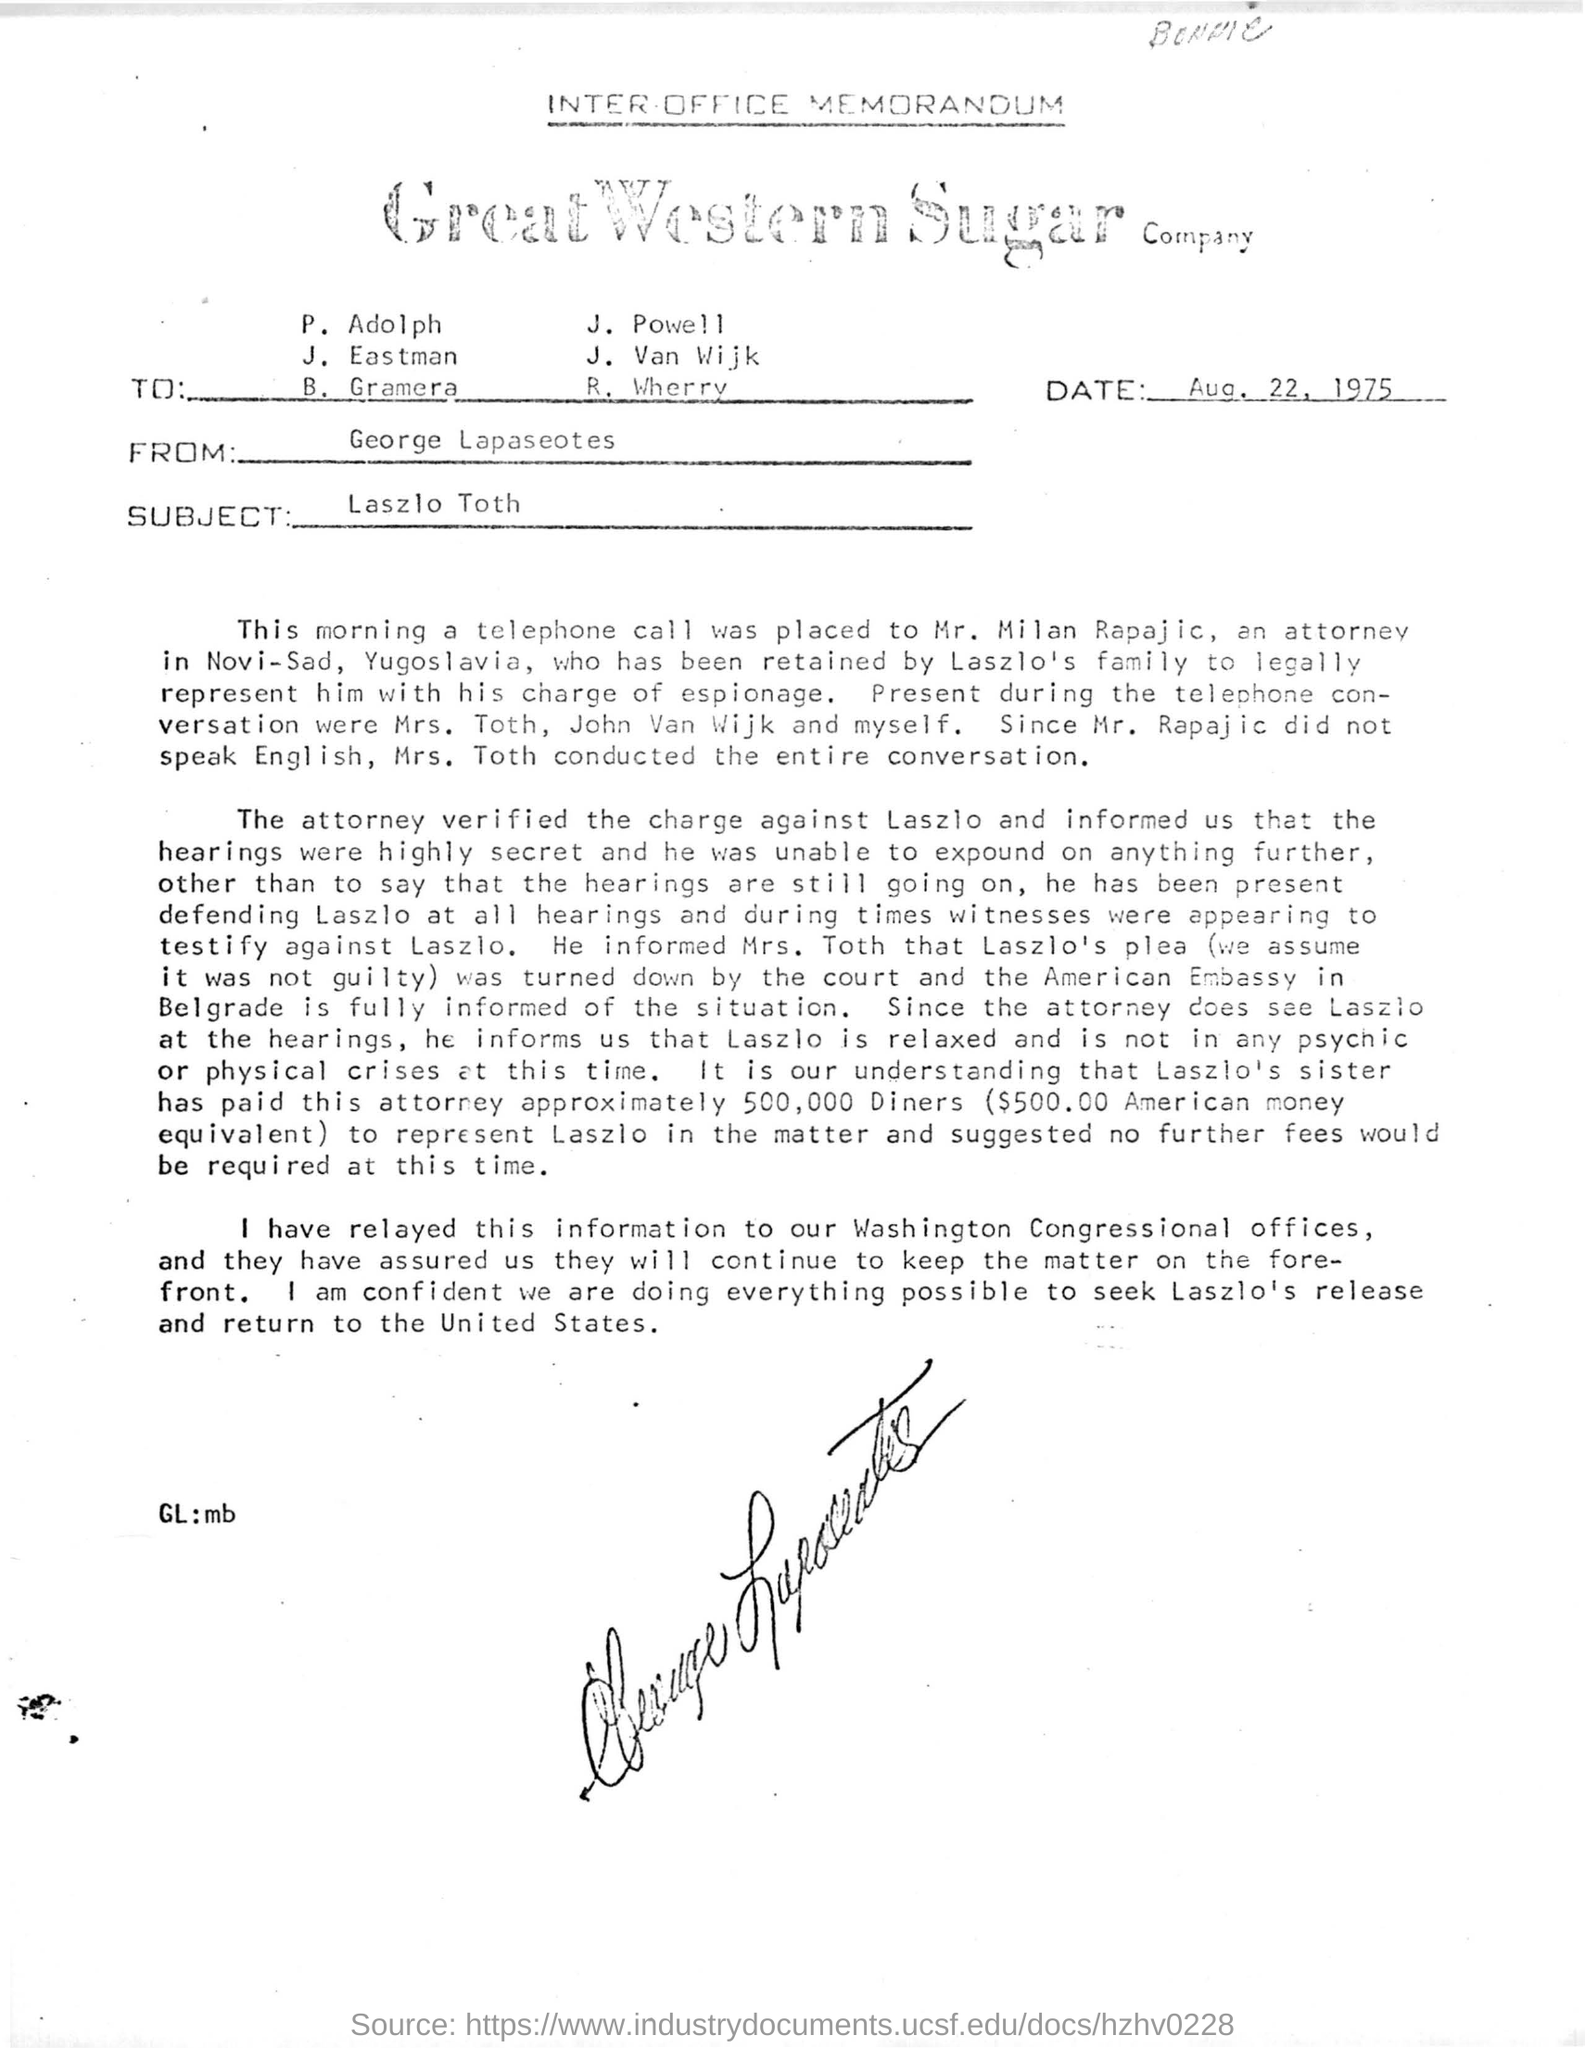From whom the  memorandum is sent
Ensure brevity in your answer.  George Lapaseotes. What is the subject of the memorandum?
Give a very brief answer. Laszlo Toth. What is the date in the memorandum?
Your response must be concise. Aug. 22, 1975. 